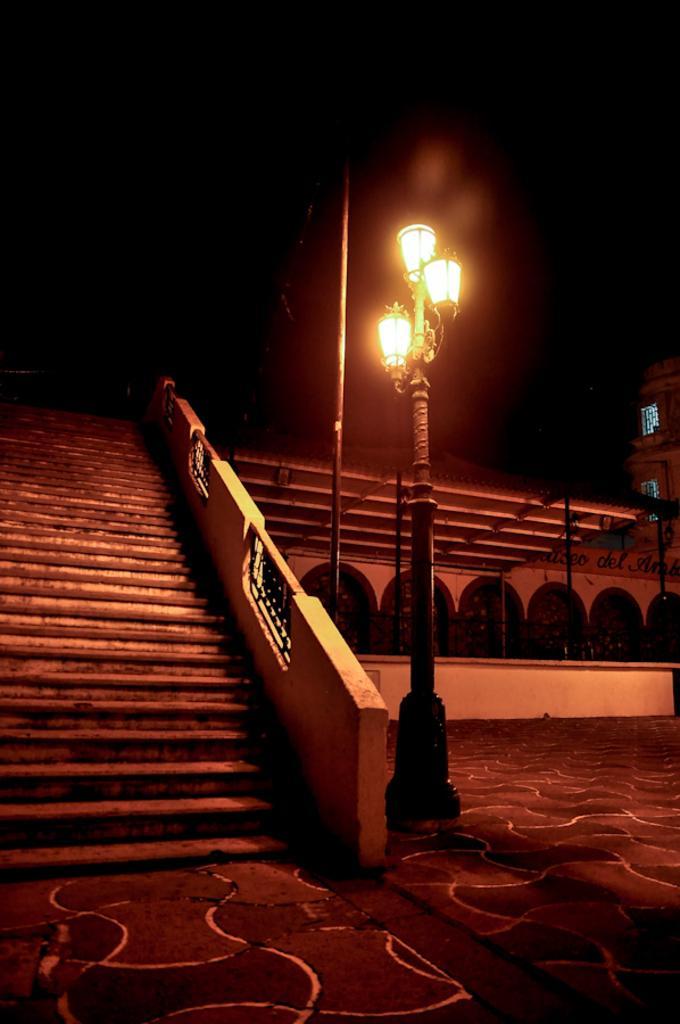Could you give a brief overview of what you see in this image? In the foreground of this picture, we see a street light. On left we see stairs. On right, we see a building and a shed. In the background, we see a pole. 